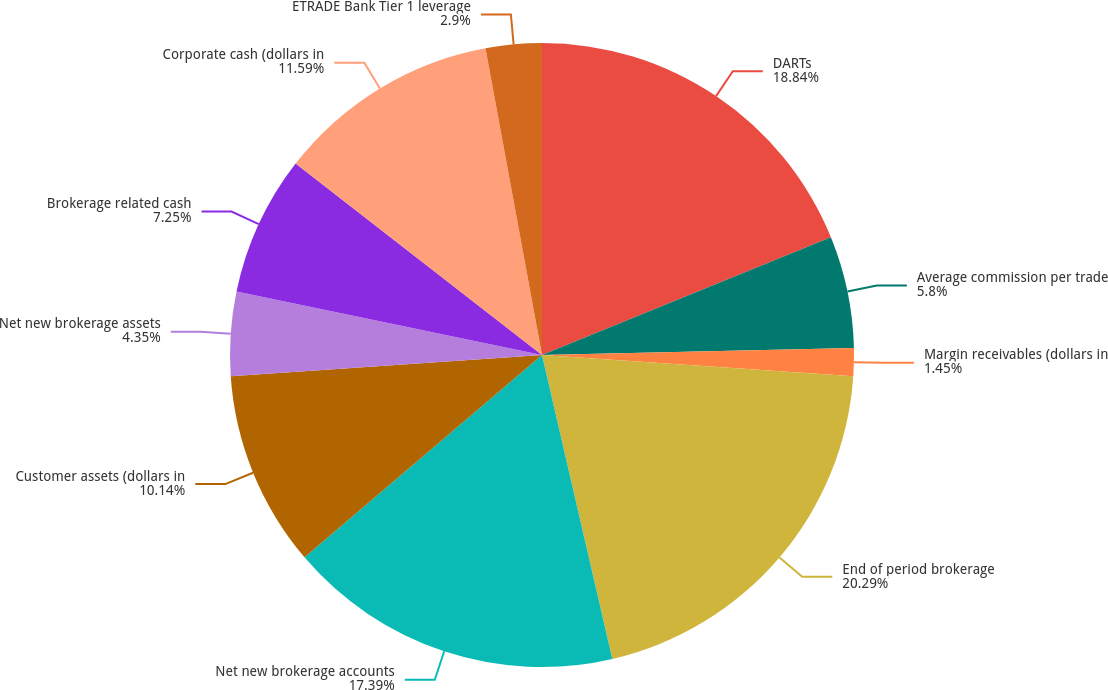Convert chart to OTSL. <chart><loc_0><loc_0><loc_500><loc_500><pie_chart><fcel>DARTs<fcel>Average commission per trade<fcel>Margin receivables (dollars in<fcel>End of period brokerage<fcel>Net new brokerage accounts<fcel>Customer assets (dollars in<fcel>Net new brokerage assets<fcel>Brokerage related cash<fcel>Corporate cash (dollars in<fcel>ETRADE Bank Tier 1 leverage<nl><fcel>18.84%<fcel>5.8%<fcel>1.45%<fcel>20.29%<fcel>17.39%<fcel>10.14%<fcel>4.35%<fcel>7.25%<fcel>11.59%<fcel>2.9%<nl></chart> 